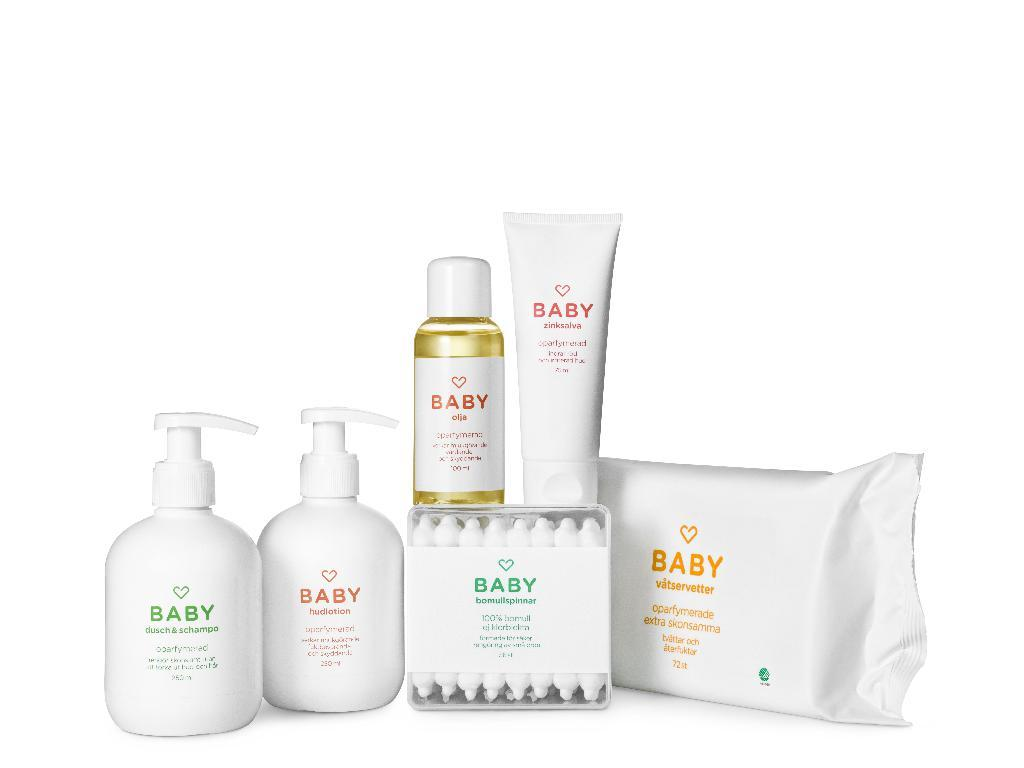<image>
Describe the image concisely. A few products from the Baby line including wipes and soaps. 